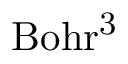<formula> <loc_0><loc_0><loc_500><loc_500>B o h r ^ { 3 }</formula> 